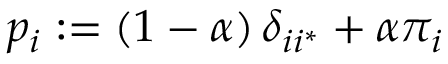Convert formula to latex. <formula><loc_0><loc_0><loc_500><loc_500>p _ { i } \colon = \left ( 1 - \alpha \right ) \delta _ { i i ^ { * } } + \alpha \pi _ { i }</formula> 